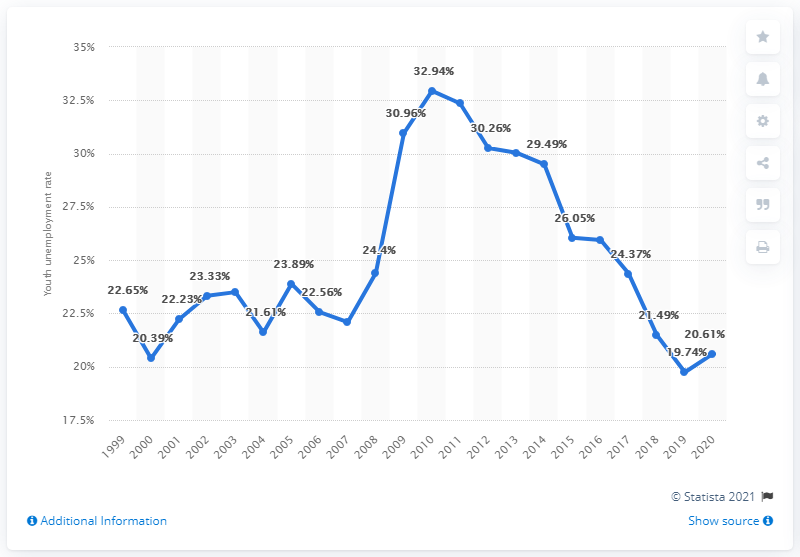Give some essential details in this illustration. In 2020, the youth unemployment rate in Puerto Rico was 20.61%. 